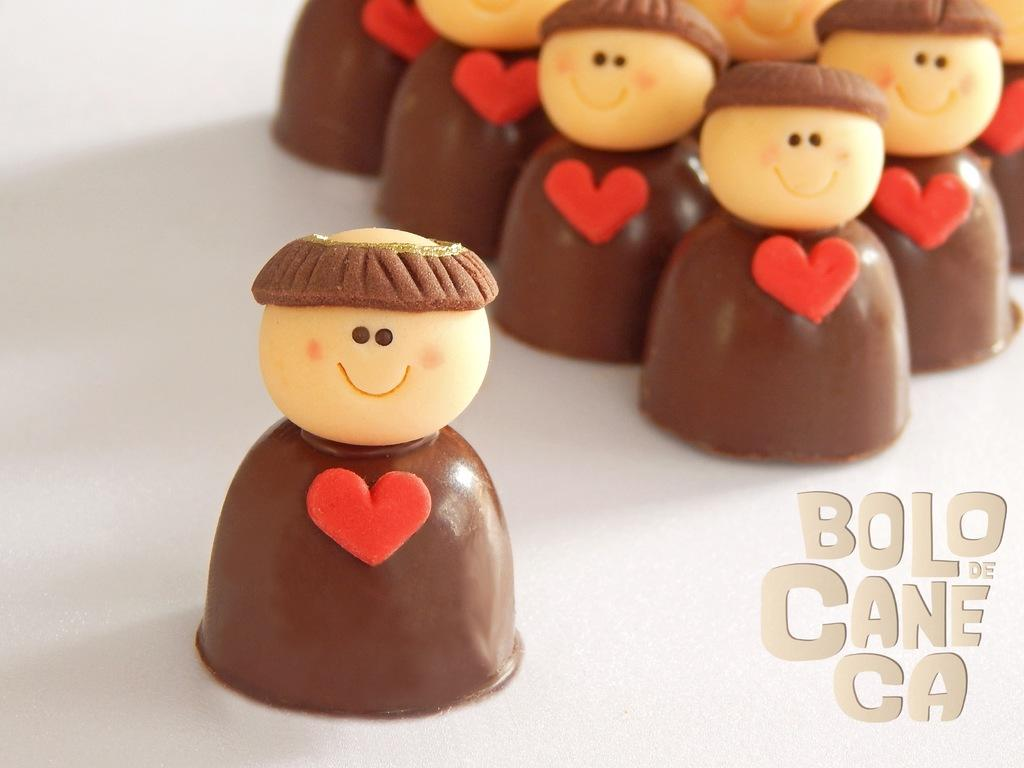What type of food is present in the image? There are chocolates in the image. What colors can be seen on the chocolates? The chocolates have cream, red, and brown colors. What is the background of the chocolates? The chocolates are on a white surface. Is there any text or writing visible in the image? Yes, there is writing on the surface. What type of fiction is being taught in the class in the image? There is no class or fiction present in the image; it features chocolates on a white surface with writing. 